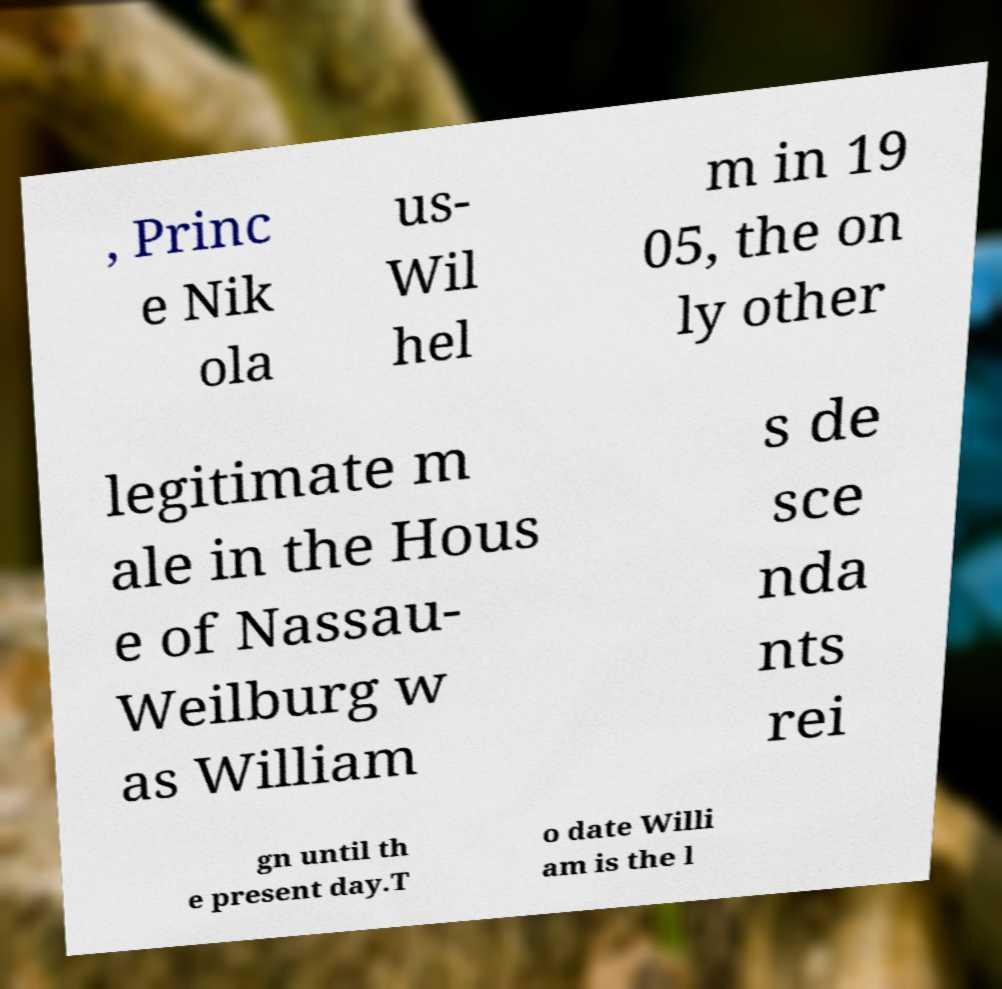Can you read and provide the text displayed in the image?This photo seems to have some interesting text. Can you extract and type it out for me? , Princ e Nik ola us- Wil hel m in 19 05, the on ly other legitimate m ale in the Hous e of Nassau- Weilburg w as William s de sce nda nts rei gn until th e present day.T o date Willi am is the l 